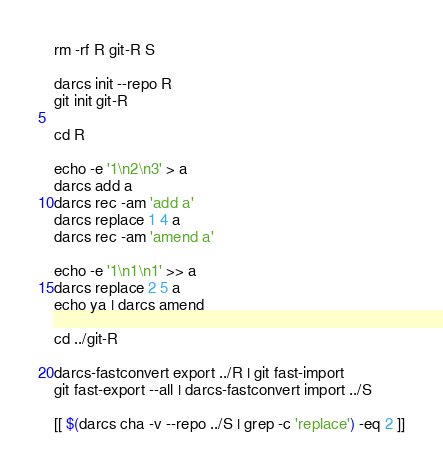Convert code to text. <code><loc_0><loc_0><loc_500><loc_500><_Bash_>rm -rf R git-R S

darcs init --repo R
git init git-R

cd R

echo -e '1\n2\n3' > a
darcs add a
darcs rec -am 'add a'
darcs replace 1 4 a
darcs rec -am 'amend a'

echo -e '1\n1\n1' >> a
darcs replace 2 5 a
echo ya | darcs amend

cd ../git-R

darcs-fastconvert export ../R | git fast-import
git fast-export --all | darcs-fastconvert import ../S

[[ $(darcs cha -v --repo ../S | grep -c 'replace') -eq 2 ]]
</code> 